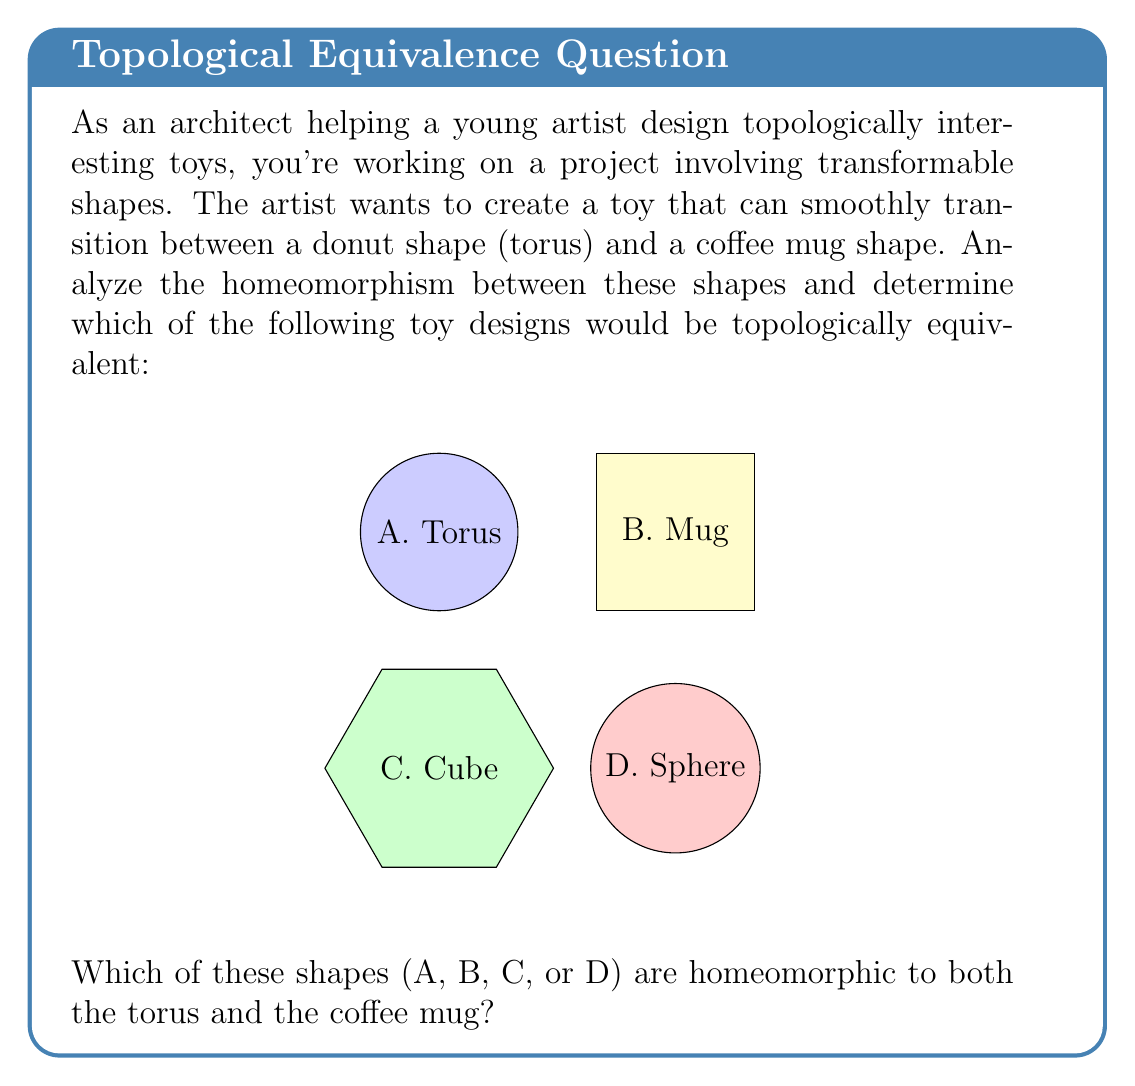Could you help me with this problem? To solve this problem, we need to understand the concept of homeomorphism in topology and analyze the properties of each shape:

1. Homeomorphism: Two shapes are homeomorphic if one can be continuously deformed into the other without cutting, tearing, or gluing.

2. Analyzing each shape:
   a) Torus (A): Has one hole
   b) Coffee Mug (B): Has one hole (the handle)
   c) Cube (C): Has no holes
   d) Sphere (D): Has no holes

3. Comparing the shapes:
   - The torus and coffee mug both have exactly one hole. They can be continuously deformed into each other by stretching and bending the torus to form the mug's body and handle, or vice versa.
   - The cube and sphere have no holes, making them topologically different from the torus and mug.

4. In topology, the number of holes (genus) is a key invariant. Shapes with the same number of holes are typically homeomorphic.

5. The homeomorphism between a torus and a coffee mug is a classic example in topology, often humorously summarized as "a topologist can't distinguish between their coffee mug and their donut."

Therefore, the shapes that are homeomorphic to both the torus and the coffee mug are options A (Torus) and B (Mug).
Answer: A and B 